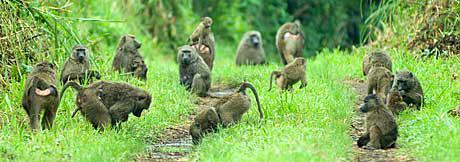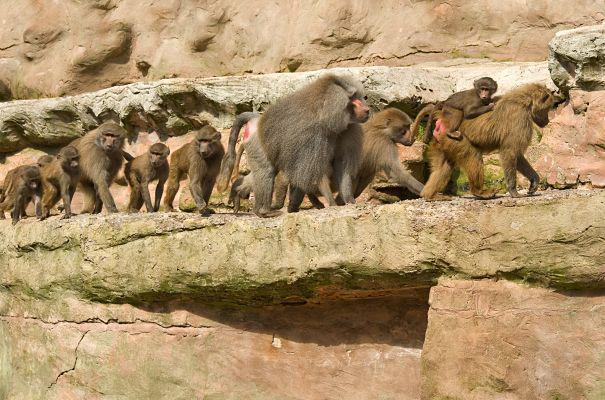The first image is the image on the left, the second image is the image on the right. Examine the images to the left and right. Is the description "There are more than seven monkeys in the image on the right." accurate? Answer yes or no. Yes. The first image is the image on the left, the second image is the image on the right. For the images shown, is this caption "An image shows at least 10 monkeys on a green field." true? Answer yes or no. Yes. 